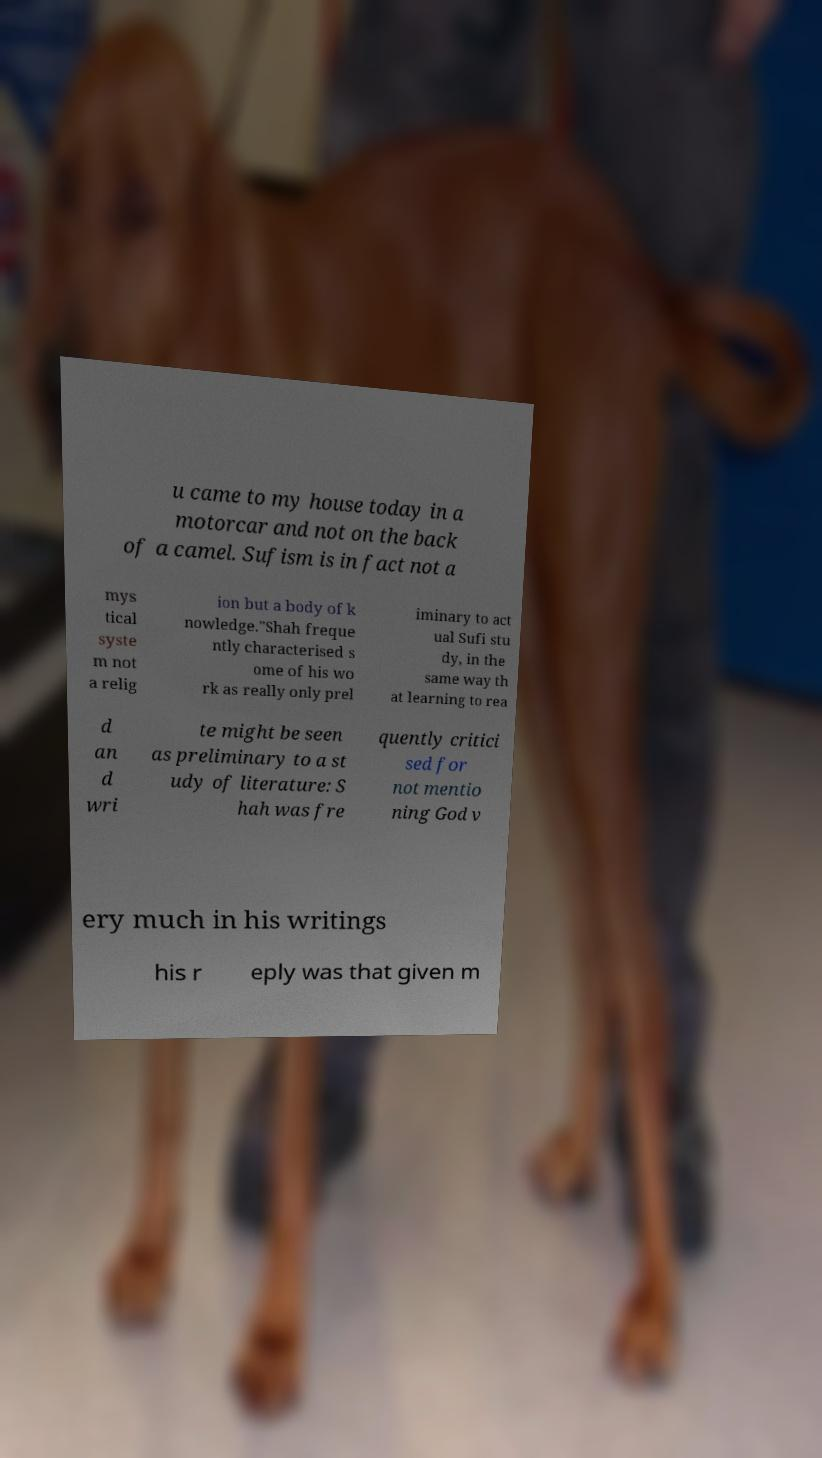For documentation purposes, I need the text within this image transcribed. Could you provide that? u came to my house today in a motorcar and not on the back of a camel. Sufism is in fact not a mys tical syste m not a relig ion but a body of k nowledge."Shah freque ntly characterised s ome of his wo rk as really only prel iminary to act ual Sufi stu dy, in the same way th at learning to rea d an d wri te might be seen as preliminary to a st udy of literature: S hah was fre quently critici sed for not mentio ning God v ery much in his writings his r eply was that given m 